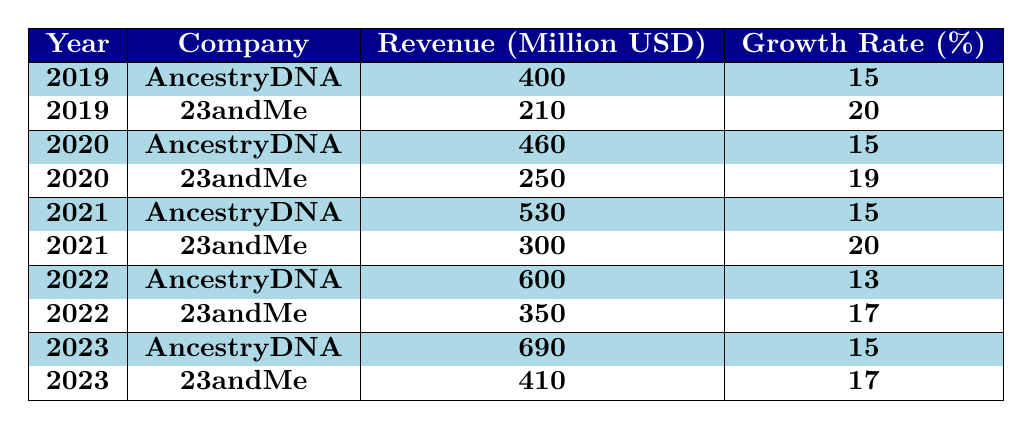What was the revenue of AncestryDNA in 2022? The table shows that in 2022, AncestryDNA's revenue was listed as 600 million USD.
Answer: 600 million USD Which company had higher revenue in 2021? In 2021, AncestryDNA had a revenue of 530 million USD while 23andMe had a revenue of 300 million USD, making AncestryDNA the one with higher revenue.
Answer: AncestryDNA What is the total revenue of both companies combined in 2023? The revenue of AncestryDNA in 2023 is 690 million USD and for 23andMe, it is 410 million USD. When adding those together, we get 690 + 410 = 1100 million USD.
Answer: 1100 million USD What is the average growth rate for AncestryDNA over the 5 years? To find the average growth rate, we add the growth rates for each year: (15 + 15 + 15 + 13 + 15) = 73. There are 5 years, so we divide by 5, which gives us 73 / 5 = 14.6%.
Answer: 14.6% Did 23andMe's revenue increase every year from 2019 to 2023? Checking the yearly revenues: 210 million USD in 2019, 250 million USD in 2020, 300 million USD in 2021, 350 million USD in 2022, and 410 million USD in 2023 shows consistent growth each year.
Answer: Yes Which year saw the largest revenue growth rate for 23andMe? The growth rates for 23andMe over the years are 20% in 2019, 19% in 2020, 20% in 2021, 17% in 2022, and 17% in 2023. The highest rate is 20%, which occurred in both 2019 and 2021.
Answer: 20% (in 2019 and 2021) What is the difference in revenue between the two companies in 2020? In 2020, AncestryDNA had a revenue of 460 million USD and 23andMe had 250 million USD. The difference is 460 - 250 = 210 million USD.
Answer: 210 million USD What was the total revenue growth percentage for AncestryDNA from 2019 to 2023? The growth rates over the years are 15% (2019-2020), 15% (2020-2021), 13% (2021-2022), and 15% (2022-2023). Summing these gives: 15 + 15 + 13 + 15 = 58%. For the entire period, we take the revenue growth from 400 million to 690 million. The percentage growth can be calculated as [(690 - 400) / 400] * 100 = 72.5%.
Answer: 72.5% (total growth) Which company had a revenue higher than 600 million USD in 2023? Checking the 2023 revenues, AncestryDNA is at 690 million USD while 23andMe is at 410 million USD, meaning only AncestryDNA surpassed the 600 million mark.
Answer: AncestryDNA 